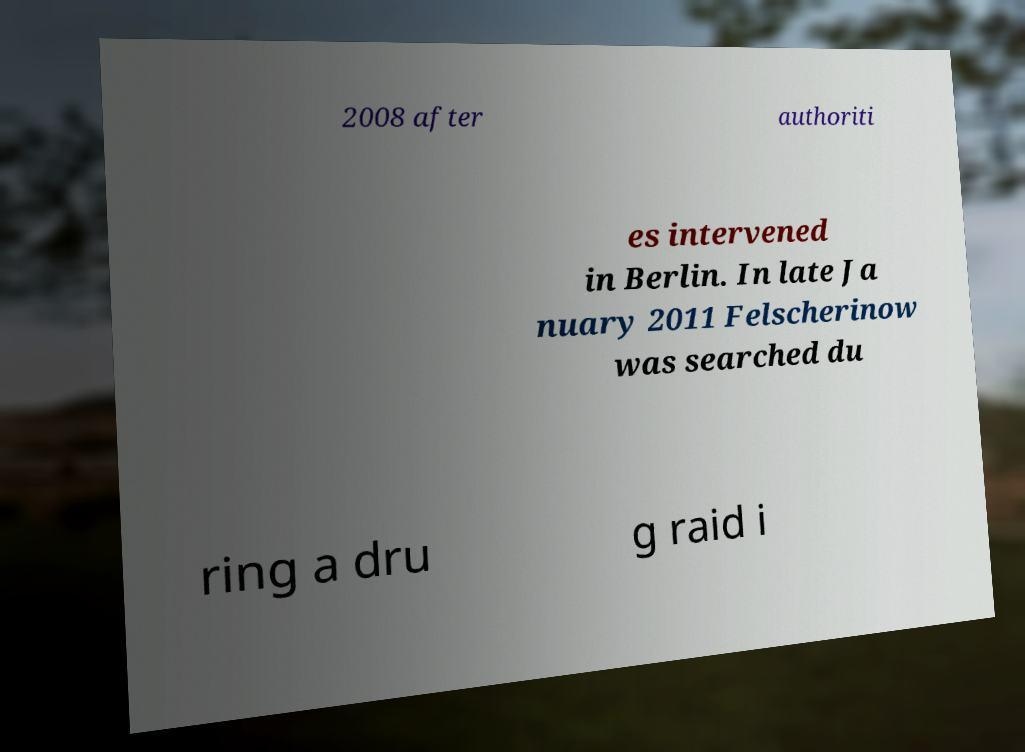Could you assist in decoding the text presented in this image and type it out clearly? 2008 after authoriti es intervened in Berlin. In late Ja nuary 2011 Felscherinow was searched du ring a dru g raid i 